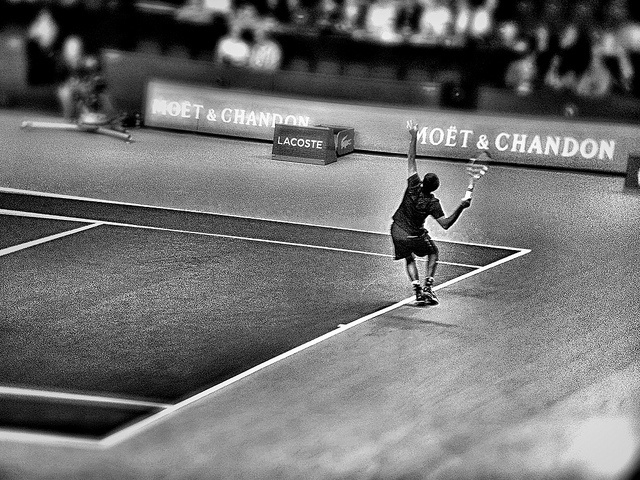Describe the objects in this image and their specific colors. I can see people in black, gray, darkgray, and lightgray tones and tennis racket in black, gray, darkgray, and lightgray tones in this image. 